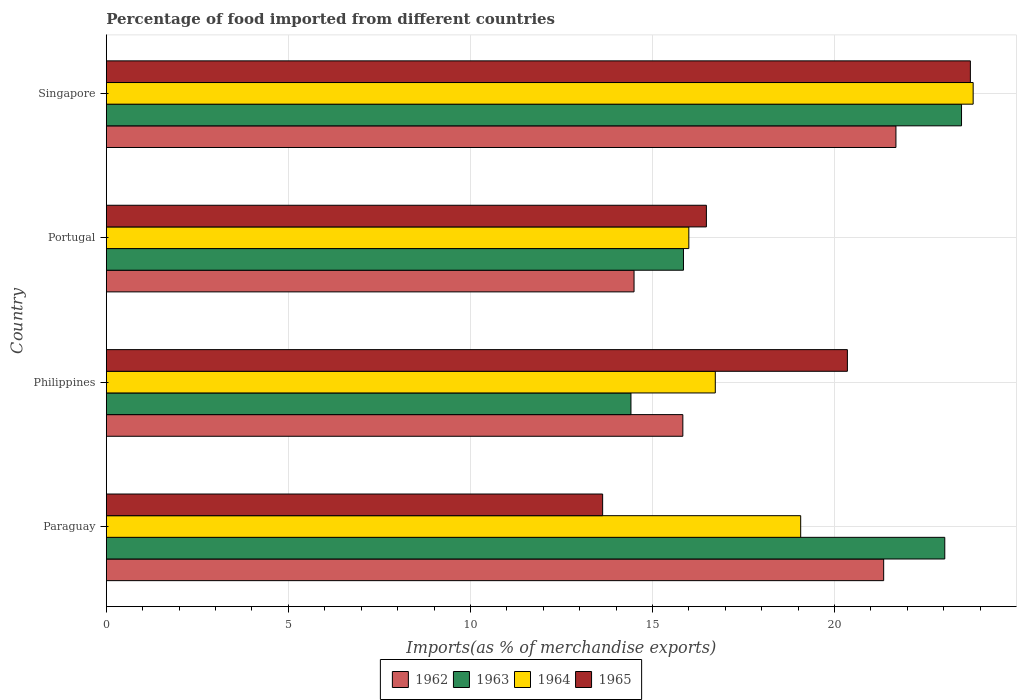Are the number of bars per tick equal to the number of legend labels?
Your answer should be compact. Yes. How many bars are there on the 3rd tick from the bottom?
Provide a succinct answer. 4. In how many cases, is the number of bars for a given country not equal to the number of legend labels?
Your answer should be compact. 0. What is the percentage of imports to different countries in 1965 in Singapore?
Make the answer very short. 23.73. Across all countries, what is the maximum percentage of imports to different countries in 1965?
Your answer should be very brief. 23.73. Across all countries, what is the minimum percentage of imports to different countries in 1964?
Provide a succinct answer. 16. In which country was the percentage of imports to different countries in 1964 maximum?
Ensure brevity in your answer.  Singapore. In which country was the percentage of imports to different countries in 1962 minimum?
Offer a very short reply. Portugal. What is the total percentage of imports to different countries in 1965 in the graph?
Your answer should be very brief. 74.2. What is the difference between the percentage of imports to different countries in 1963 in Paraguay and that in Portugal?
Provide a short and direct response. 7.18. What is the difference between the percentage of imports to different countries in 1963 in Portugal and the percentage of imports to different countries in 1964 in Singapore?
Ensure brevity in your answer.  -7.96. What is the average percentage of imports to different countries in 1964 per country?
Provide a short and direct response. 18.9. What is the difference between the percentage of imports to different countries in 1962 and percentage of imports to different countries in 1965 in Paraguay?
Your response must be concise. 7.72. In how many countries, is the percentage of imports to different countries in 1963 greater than 2 %?
Offer a very short reply. 4. What is the ratio of the percentage of imports to different countries in 1962 in Paraguay to that in Singapore?
Provide a short and direct response. 0.98. Is the difference between the percentage of imports to different countries in 1962 in Paraguay and Singapore greater than the difference between the percentage of imports to different countries in 1965 in Paraguay and Singapore?
Provide a short and direct response. Yes. What is the difference between the highest and the second highest percentage of imports to different countries in 1962?
Your response must be concise. 0.34. What is the difference between the highest and the lowest percentage of imports to different countries in 1962?
Keep it short and to the point. 7.19. In how many countries, is the percentage of imports to different countries in 1962 greater than the average percentage of imports to different countries in 1962 taken over all countries?
Keep it short and to the point. 2. Is it the case that in every country, the sum of the percentage of imports to different countries in 1965 and percentage of imports to different countries in 1963 is greater than the sum of percentage of imports to different countries in 1962 and percentage of imports to different countries in 1964?
Provide a succinct answer. No. What does the 3rd bar from the top in Paraguay represents?
Keep it short and to the point. 1963. What does the 3rd bar from the bottom in Singapore represents?
Provide a succinct answer. 1964. Is it the case that in every country, the sum of the percentage of imports to different countries in 1963 and percentage of imports to different countries in 1964 is greater than the percentage of imports to different countries in 1962?
Offer a terse response. Yes. How many countries are there in the graph?
Your answer should be very brief. 4. Are the values on the major ticks of X-axis written in scientific E-notation?
Ensure brevity in your answer.  No. Does the graph contain grids?
Give a very brief answer. Yes. Where does the legend appear in the graph?
Your answer should be very brief. Bottom center. What is the title of the graph?
Your answer should be very brief. Percentage of food imported from different countries. What is the label or title of the X-axis?
Ensure brevity in your answer.  Imports(as % of merchandise exports). What is the Imports(as % of merchandise exports) in 1962 in Paraguay?
Keep it short and to the point. 21.35. What is the Imports(as % of merchandise exports) in 1963 in Paraguay?
Your answer should be compact. 23.03. What is the Imports(as % of merchandise exports) in 1964 in Paraguay?
Offer a terse response. 19.07. What is the Imports(as % of merchandise exports) in 1965 in Paraguay?
Give a very brief answer. 13.63. What is the Imports(as % of merchandise exports) in 1962 in Philippines?
Your response must be concise. 15.83. What is the Imports(as % of merchandise exports) in 1963 in Philippines?
Make the answer very short. 14.41. What is the Imports(as % of merchandise exports) in 1964 in Philippines?
Your answer should be compact. 16.73. What is the Imports(as % of merchandise exports) in 1965 in Philippines?
Your response must be concise. 20.35. What is the Imports(as % of merchandise exports) in 1962 in Portugal?
Provide a short and direct response. 14.49. What is the Imports(as % of merchandise exports) of 1963 in Portugal?
Offer a very short reply. 15.85. What is the Imports(as % of merchandise exports) in 1964 in Portugal?
Give a very brief answer. 16. What is the Imports(as % of merchandise exports) of 1965 in Portugal?
Ensure brevity in your answer.  16.48. What is the Imports(as % of merchandise exports) in 1962 in Singapore?
Keep it short and to the point. 21.69. What is the Imports(as % of merchandise exports) in 1963 in Singapore?
Your response must be concise. 23.49. What is the Imports(as % of merchandise exports) of 1964 in Singapore?
Your response must be concise. 23.81. What is the Imports(as % of merchandise exports) of 1965 in Singapore?
Offer a terse response. 23.73. Across all countries, what is the maximum Imports(as % of merchandise exports) of 1962?
Your answer should be very brief. 21.69. Across all countries, what is the maximum Imports(as % of merchandise exports) of 1963?
Your answer should be compact. 23.49. Across all countries, what is the maximum Imports(as % of merchandise exports) in 1964?
Keep it short and to the point. 23.81. Across all countries, what is the maximum Imports(as % of merchandise exports) in 1965?
Give a very brief answer. 23.73. Across all countries, what is the minimum Imports(as % of merchandise exports) in 1962?
Provide a succinct answer. 14.49. Across all countries, what is the minimum Imports(as % of merchandise exports) in 1963?
Your response must be concise. 14.41. Across all countries, what is the minimum Imports(as % of merchandise exports) in 1964?
Keep it short and to the point. 16. Across all countries, what is the minimum Imports(as % of merchandise exports) of 1965?
Provide a short and direct response. 13.63. What is the total Imports(as % of merchandise exports) in 1962 in the graph?
Your answer should be very brief. 73.37. What is the total Imports(as % of merchandise exports) in 1963 in the graph?
Provide a short and direct response. 76.78. What is the total Imports(as % of merchandise exports) in 1964 in the graph?
Provide a succinct answer. 75.61. What is the total Imports(as % of merchandise exports) in 1965 in the graph?
Your answer should be very brief. 74.2. What is the difference between the Imports(as % of merchandise exports) in 1962 in Paraguay and that in Philippines?
Provide a short and direct response. 5.52. What is the difference between the Imports(as % of merchandise exports) of 1963 in Paraguay and that in Philippines?
Your answer should be very brief. 8.62. What is the difference between the Imports(as % of merchandise exports) in 1964 in Paraguay and that in Philippines?
Provide a short and direct response. 2.35. What is the difference between the Imports(as % of merchandise exports) in 1965 in Paraguay and that in Philippines?
Your response must be concise. -6.72. What is the difference between the Imports(as % of merchandise exports) of 1962 in Paraguay and that in Portugal?
Offer a very short reply. 6.86. What is the difference between the Imports(as % of merchandise exports) in 1963 in Paraguay and that in Portugal?
Provide a succinct answer. 7.18. What is the difference between the Imports(as % of merchandise exports) of 1964 in Paraguay and that in Portugal?
Your answer should be compact. 3.07. What is the difference between the Imports(as % of merchandise exports) in 1965 in Paraguay and that in Portugal?
Your answer should be compact. -2.85. What is the difference between the Imports(as % of merchandise exports) in 1962 in Paraguay and that in Singapore?
Offer a terse response. -0.34. What is the difference between the Imports(as % of merchandise exports) of 1963 in Paraguay and that in Singapore?
Make the answer very short. -0.46. What is the difference between the Imports(as % of merchandise exports) in 1964 in Paraguay and that in Singapore?
Offer a very short reply. -4.74. What is the difference between the Imports(as % of merchandise exports) of 1965 in Paraguay and that in Singapore?
Make the answer very short. -10.1. What is the difference between the Imports(as % of merchandise exports) in 1962 in Philippines and that in Portugal?
Your answer should be very brief. 1.34. What is the difference between the Imports(as % of merchandise exports) of 1963 in Philippines and that in Portugal?
Keep it short and to the point. -1.44. What is the difference between the Imports(as % of merchandise exports) of 1964 in Philippines and that in Portugal?
Give a very brief answer. 0.73. What is the difference between the Imports(as % of merchandise exports) of 1965 in Philippines and that in Portugal?
Your response must be concise. 3.87. What is the difference between the Imports(as % of merchandise exports) in 1962 in Philippines and that in Singapore?
Your response must be concise. -5.85. What is the difference between the Imports(as % of merchandise exports) of 1963 in Philippines and that in Singapore?
Provide a succinct answer. -9.08. What is the difference between the Imports(as % of merchandise exports) in 1964 in Philippines and that in Singapore?
Your response must be concise. -7.08. What is the difference between the Imports(as % of merchandise exports) of 1965 in Philippines and that in Singapore?
Keep it short and to the point. -3.38. What is the difference between the Imports(as % of merchandise exports) in 1962 in Portugal and that in Singapore?
Provide a short and direct response. -7.19. What is the difference between the Imports(as % of merchandise exports) in 1963 in Portugal and that in Singapore?
Your answer should be compact. -7.64. What is the difference between the Imports(as % of merchandise exports) of 1964 in Portugal and that in Singapore?
Your answer should be very brief. -7.81. What is the difference between the Imports(as % of merchandise exports) in 1965 in Portugal and that in Singapore?
Keep it short and to the point. -7.25. What is the difference between the Imports(as % of merchandise exports) in 1962 in Paraguay and the Imports(as % of merchandise exports) in 1963 in Philippines?
Offer a terse response. 6.94. What is the difference between the Imports(as % of merchandise exports) in 1962 in Paraguay and the Imports(as % of merchandise exports) in 1964 in Philippines?
Make the answer very short. 4.62. What is the difference between the Imports(as % of merchandise exports) of 1963 in Paraguay and the Imports(as % of merchandise exports) of 1964 in Philippines?
Make the answer very short. 6.3. What is the difference between the Imports(as % of merchandise exports) of 1963 in Paraguay and the Imports(as % of merchandise exports) of 1965 in Philippines?
Offer a very short reply. 2.67. What is the difference between the Imports(as % of merchandise exports) of 1964 in Paraguay and the Imports(as % of merchandise exports) of 1965 in Philippines?
Keep it short and to the point. -1.28. What is the difference between the Imports(as % of merchandise exports) in 1962 in Paraguay and the Imports(as % of merchandise exports) in 1963 in Portugal?
Your response must be concise. 5.5. What is the difference between the Imports(as % of merchandise exports) in 1962 in Paraguay and the Imports(as % of merchandise exports) in 1964 in Portugal?
Keep it short and to the point. 5.35. What is the difference between the Imports(as % of merchandise exports) in 1962 in Paraguay and the Imports(as % of merchandise exports) in 1965 in Portugal?
Your answer should be compact. 4.87. What is the difference between the Imports(as % of merchandise exports) in 1963 in Paraguay and the Imports(as % of merchandise exports) in 1964 in Portugal?
Ensure brevity in your answer.  7.03. What is the difference between the Imports(as % of merchandise exports) in 1963 in Paraguay and the Imports(as % of merchandise exports) in 1965 in Portugal?
Your response must be concise. 6.55. What is the difference between the Imports(as % of merchandise exports) in 1964 in Paraguay and the Imports(as % of merchandise exports) in 1965 in Portugal?
Offer a terse response. 2.59. What is the difference between the Imports(as % of merchandise exports) of 1962 in Paraguay and the Imports(as % of merchandise exports) of 1963 in Singapore?
Make the answer very short. -2.14. What is the difference between the Imports(as % of merchandise exports) of 1962 in Paraguay and the Imports(as % of merchandise exports) of 1964 in Singapore?
Make the answer very short. -2.46. What is the difference between the Imports(as % of merchandise exports) of 1962 in Paraguay and the Imports(as % of merchandise exports) of 1965 in Singapore?
Your response must be concise. -2.38. What is the difference between the Imports(as % of merchandise exports) in 1963 in Paraguay and the Imports(as % of merchandise exports) in 1964 in Singapore?
Provide a succinct answer. -0.78. What is the difference between the Imports(as % of merchandise exports) in 1963 in Paraguay and the Imports(as % of merchandise exports) in 1965 in Singapore?
Provide a succinct answer. -0.7. What is the difference between the Imports(as % of merchandise exports) in 1964 in Paraguay and the Imports(as % of merchandise exports) in 1965 in Singapore?
Provide a short and direct response. -4.66. What is the difference between the Imports(as % of merchandise exports) of 1962 in Philippines and the Imports(as % of merchandise exports) of 1963 in Portugal?
Ensure brevity in your answer.  -0.02. What is the difference between the Imports(as % of merchandise exports) of 1962 in Philippines and the Imports(as % of merchandise exports) of 1964 in Portugal?
Give a very brief answer. -0.16. What is the difference between the Imports(as % of merchandise exports) of 1962 in Philippines and the Imports(as % of merchandise exports) of 1965 in Portugal?
Make the answer very short. -0.65. What is the difference between the Imports(as % of merchandise exports) in 1963 in Philippines and the Imports(as % of merchandise exports) in 1964 in Portugal?
Your answer should be compact. -1.59. What is the difference between the Imports(as % of merchandise exports) in 1963 in Philippines and the Imports(as % of merchandise exports) in 1965 in Portugal?
Offer a terse response. -2.07. What is the difference between the Imports(as % of merchandise exports) in 1964 in Philippines and the Imports(as % of merchandise exports) in 1965 in Portugal?
Ensure brevity in your answer.  0.24. What is the difference between the Imports(as % of merchandise exports) of 1962 in Philippines and the Imports(as % of merchandise exports) of 1963 in Singapore?
Your answer should be compact. -7.65. What is the difference between the Imports(as % of merchandise exports) in 1962 in Philippines and the Imports(as % of merchandise exports) in 1964 in Singapore?
Offer a terse response. -7.97. What is the difference between the Imports(as % of merchandise exports) of 1962 in Philippines and the Imports(as % of merchandise exports) of 1965 in Singapore?
Your answer should be very brief. -7.9. What is the difference between the Imports(as % of merchandise exports) of 1963 in Philippines and the Imports(as % of merchandise exports) of 1964 in Singapore?
Ensure brevity in your answer.  -9.4. What is the difference between the Imports(as % of merchandise exports) of 1963 in Philippines and the Imports(as % of merchandise exports) of 1965 in Singapore?
Give a very brief answer. -9.32. What is the difference between the Imports(as % of merchandise exports) in 1964 in Philippines and the Imports(as % of merchandise exports) in 1965 in Singapore?
Provide a short and direct response. -7.01. What is the difference between the Imports(as % of merchandise exports) in 1962 in Portugal and the Imports(as % of merchandise exports) in 1963 in Singapore?
Your answer should be very brief. -8.99. What is the difference between the Imports(as % of merchandise exports) in 1962 in Portugal and the Imports(as % of merchandise exports) in 1964 in Singapore?
Make the answer very short. -9.31. What is the difference between the Imports(as % of merchandise exports) in 1962 in Portugal and the Imports(as % of merchandise exports) in 1965 in Singapore?
Your response must be concise. -9.24. What is the difference between the Imports(as % of merchandise exports) in 1963 in Portugal and the Imports(as % of merchandise exports) in 1964 in Singapore?
Make the answer very short. -7.96. What is the difference between the Imports(as % of merchandise exports) of 1963 in Portugal and the Imports(as % of merchandise exports) of 1965 in Singapore?
Provide a short and direct response. -7.88. What is the difference between the Imports(as % of merchandise exports) in 1964 in Portugal and the Imports(as % of merchandise exports) in 1965 in Singapore?
Provide a short and direct response. -7.73. What is the average Imports(as % of merchandise exports) of 1962 per country?
Ensure brevity in your answer.  18.34. What is the average Imports(as % of merchandise exports) of 1963 per country?
Your answer should be compact. 19.2. What is the average Imports(as % of merchandise exports) in 1964 per country?
Keep it short and to the point. 18.9. What is the average Imports(as % of merchandise exports) in 1965 per country?
Offer a terse response. 18.55. What is the difference between the Imports(as % of merchandise exports) of 1962 and Imports(as % of merchandise exports) of 1963 in Paraguay?
Your answer should be compact. -1.68. What is the difference between the Imports(as % of merchandise exports) of 1962 and Imports(as % of merchandise exports) of 1964 in Paraguay?
Provide a succinct answer. 2.28. What is the difference between the Imports(as % of merchandise exports) in 1962 and Imports(as % of merchandise exports) in 1965 in Paraguay?
Offer a terse response. 7.72. What is the difference between the Imports(as % of merchandise exports) of 1963 and Imports(as % of merchandise exports) of 1964 in Paraguay?
Give a very brief answer. 3.96. What is the difference between the Imports(as % of merchandise exports) of 1963 and Imports(as % of merchandise exports) of 1965 in Paraguay?
Keep it short and to the point. 9.4. What is the difference between the Imports(as % of merchandise exports) in 1964 and Imports(as % of merchandise exports) in 1965 in Paraguay?
Provide a succinct answer. 5.44. What is the difference between the Imports(as % of merchandise exports) of 1962 and Imports(as % of merchandise exports) of 1963 in Philippines?
Your response must be concise. 1.43. What is the difference between the Imports(as % of merchandise exports) of 1962 and Imports(as % of merchandise exports) of 1964 in Philippines?
Provide a short and direct response. -0.89. What is the difference between the Imports(as % of merchandise exports) of 1962 and Imports(as % of merchandise exports) of 1965 in Philippines?
Ensure brevity in your answer.  -4.52. What is the difference between the Imports(as % of merchandise exports) in 1963 and Imports(as % of merchandise exports) in 1964 in Philippines?
Your answer should be very brief. -2.32. What is the difference between the Imports(as % of merchandise exports) in 1963 and Imports(as % of merchandise exports) in 1965 in Philippines?
Your answer should be compact. -5.94. What is the difference between the Imports(as % of merchandise exports) of 1964 and Imports(as % of merchandise exports) of 1965 in Philippines?
Keep it short and to the point. -3.63. What is the difference between the Imports(as % of merchandise exports) of 1962 and Imports(as % of merchandise exports) of 1963 in Portugal?
Your response must be concise. -1.36. What is the difference between the Imports(as % of merchandise exports) in 1962 and Imports(as % of merchandise exports) in 1964 in Portugal?
Your answer should be very brief. -1.5. What is the difference between the Imports(as % of merchandise exports) in 1962 and Imports(as % of merchandise exports) in 1965 in Portugal?
Your answer should be very brief. -1.99. What is the difference between the Imports(as % of merchandise exports) of 1963 and Imports(as % of merchandise exports) of 1964 in Portugal?
Offer a terse response. -0.15. What is the difference between the Imports(as % of merchandise exports) of 1963 and Imports(as % of merchandise exports) of 1965 in Portugal?
Make the answer very short. -0.63. What is the difference between the Imports(as % of merchandise exports) in 1964 and Imports(as % of merchandise exports) in 1965 in Portugal?
Make the answer very short. -0.48. What is the difference between the Imports(as % of merchandise exports) in 1962 and Imports(as % of merchandise exports) in 1963 in Singapore?
Ensure brevity in your answer.  -1.8. What is the difference between the Imports(as % of merchandise exports) of 1962 and Imports(as % of merchandise exports) of 1964 in Singapore?
Make the answer very short. -2.12. What is the difference between the Imports(as % of merchandise exports) in 1962 and Imports(as % of merchandise exports) in 1965 in Singapore?
Your response must be concise. -2.04. What is the difference between the Imports(as % of merchandise exports) of 1963 and Imports(as % of merchandise exports) of 1964 in Singapore?
Your answer should be very brief. -0.32. What is the difference between the Imports(as % of merchandise exports) in 1963 and Imports(as % of merchandise exports) in 1965 in Singapore?
Your response must be concise. -0.24. What is the difference between the Imports(as % of merchandise exports) in 1964 and Imports(as % of merchandise exports) in 1965 in Singapore?
Give a very brief answer. 0.08. What is the ratio of the Imports(as % of merchandise exports) in 1962 in Paraguay to that in Philippines?
Offer a very short reply. 1.35. What is the ratio of the Imports(as % of merchandise exports) of 1963 in Paraguay to that in Philippines?
Offer a terse response. 1.6. What is the ratio of the Imports(as % of merchandise exports) in 1964 in Paraguay to that in Philippines?
Provide a short and direct response. 1.14. What is the ratio of the Imports(as % of merchandise exports) in 1965 in Paraguay to that in Philippines?
Your answer should be compact. 0.67. What is the ratio of the Imports(as % of merchandise exports) in 1962 in Paraguay to that in Portugal?
Your answer should be compact. 1.47. What is the ratio of the Imports(as % of merchandise exports) in 1963 in Paraguay to that in Portugal?
Your response must be concise. 1.45. What is the ratio of the Imports(as % of merchandise exports) of 1964 in Paraguay to that in Portugal?
Keep it short and to the point. 1.19. What is the ratio of the Imports(as % of merchandise exports) in 1965 in Paraguay to that in Portugal?
Your answer should be very brief. 0.83. What is the ratio of the Imports(as % of merchandise exports) in 1962 in Paraguay to that in Singapore?
Offer a terse response. 0.98. What is the ratio of the Imports(as % of merchandise exports) of 1963 in Paraguay to that in Singapore?
Your answer should be compact. 0.98. What is the ratio of the Imports(as % of merchandise exports) of 1964 in Paraguay to that in Singapore?
Ensure brevity in your answer.  0.8. What is the ratio of the Imports(as % of merchandise exports) in 1965 in Paraguay to that in Singapore?
Ensure brevity in your answer.  0.57. What is the ratio of the Imports(as % of merchandise exports) in 1962 in Philippines to that in Portugal?
Ensure brevity in your answer.  1.09. What is the ratio of the Imports(as % of merchandise exports) of 1963 in Philippines to that in Portugal?
Your answer should be very brief. 0.91. What is the ratio of the Imports(as % of merchandise exports) in 1964 in Philippines to that in Portugal?
Make the answer very short. 1.05. What is the ratio of the Imports(as % of merchandise exports) in 1965 in Philippines to that in Portugal?
Provide a short and direct response. 1.24. What is the ratio of the Imports(as % of merchandise exports) of 1962 in Philippines to that in Singapore?
Provide a short and direct response. 0.73. What is the ratio of the Imports(as % of merchandise exports) in 1963 in Philippines to that in Singapore?
Keep it short and to the point. 0.61. What is the ratio of the Imports(as % of merchandise exports) of 1964 in Philippines to that in Singapore?
Your answer should be very brief. 0.7. What is the ratio of the Imports(as % of merchandise exports) of 1965 in Philippines to that in Singapore?
Keep it short and to the point. 0.86. What is the ratio of the Imports(as % of merchandise exports) in 1962 in Portugal to that in Singapore?
Your response must be concise. 0.67. What is the ratio of the Imports(as % of merchandise exports) in 1963 in Portugal to that in Singapore?
Make the answer very short. 0.67. What is the ratio of the Imports(as % of merchandise exports) of 1964 in Portugal to that in Singapore?
Offer a terse response. 0.67. What is the ratio of the Imports(as % of merchandise exports) of 1965 in Portugal to that in Singapore?
Make the answer very short. 0.69. What is the difference between the highest and the second highest Imports(as % of merchandise exports) of 1962?
Provide a succinct answer. 0.34. What is the difference between the highest and the second highest Imports(as % of merchandise exports) in 1963?
Keep it short and to the point. 0.46. What is the difference between the highest and the second highest Imports(as % of merchandise exports) of 1964?
Keep it short and to the point. 4.74. What is the difference between the highest and the second highest Imports(as % of merchandise exports) of 1965?
Provide a short and direct response. 3.38. What is the difference between the highest and the lowest Imports(as % of merchandise exports) of 1962?
Give a very brief answer. 7.19. What is the difference between the highest and the lowest Imports(as % of merchandise exports) in 1963?
Provide a succinct answer. 9.08. What is the difference between the highest and the lowest Imports(as % of merchandise exports) in 1964?
Ensure brevity in your answer.  7.81. What is the difference between the highest and the lowest Imports(as % of merchandise exports) of 1965?
Offer a very short reply. 10.1. 